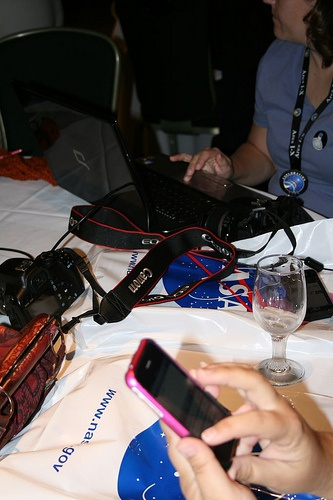Describe the objects in this image and their specific colors. I can see people in black, darkblue, and maroon tones, laptop in black, maroon, and gray tones, people in black, tan, and gray tones, cell phone in black, maroon, violet, and lavender tones, and wine glass in black, darkgray, gray, and lightgray tones in this image. 